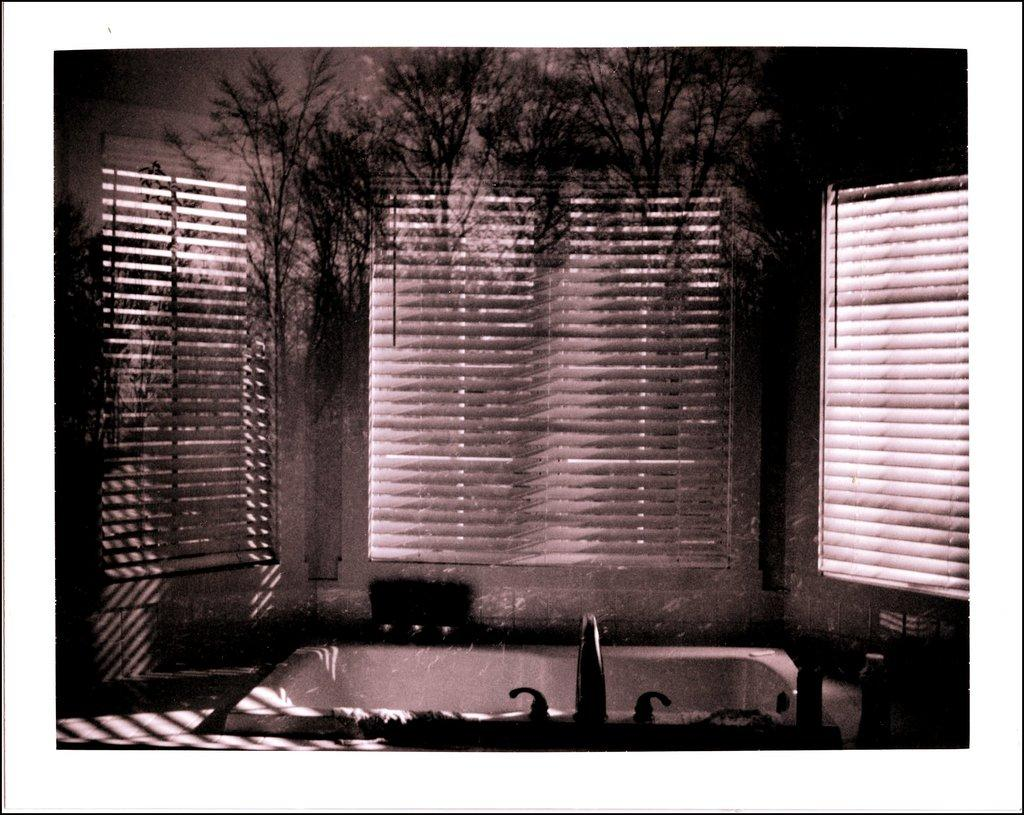What type of image is being described? The image is an edited picture. What can be seen inside the bathroom in the image? There is a bath tub and a tap in the image. What type of window treatment is present in the image? There are windows with window blinds in the image. What has been added to the background of the image? The background of the image has been post-processed with trees. How many circles can be seen in the image? There are no circles present in the image. What type of flock is visible in the image? There is no flock visible in the image. 